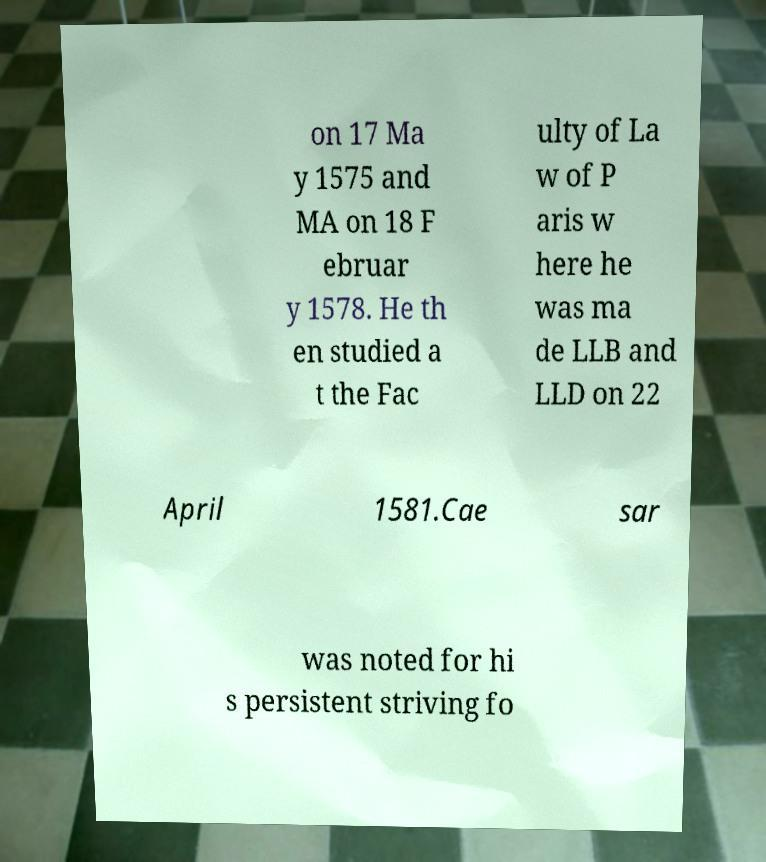Can you accurately transcribe the text from the provided image for me? on 17 Ma y 1575 and MA on 18 F ebruar y 1578. He th en studied a t the Fac ulty of La w of P aris w here he was ma de LLB and LLD on 22 April 1581.Cae sar was noted for hi s persistent striving fo 